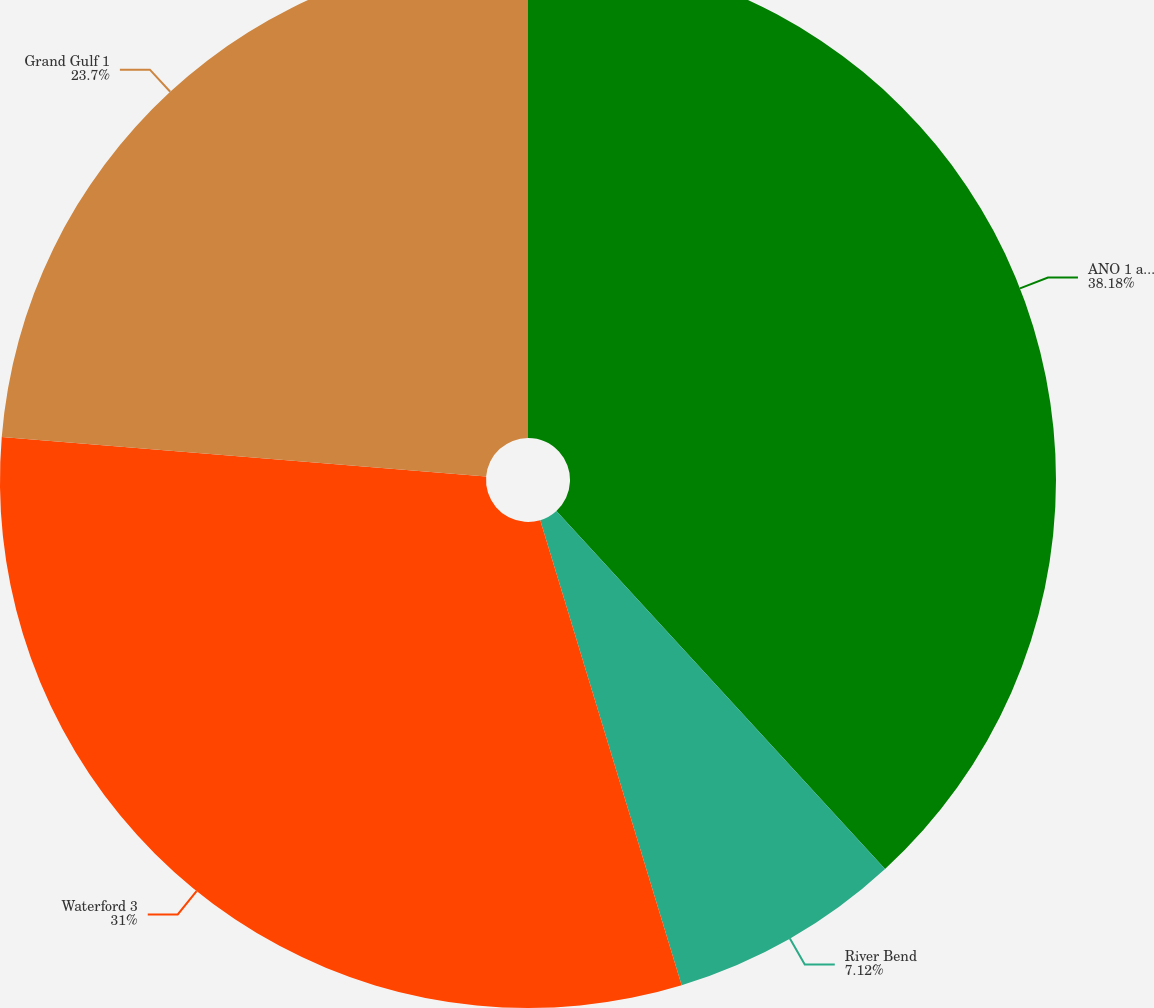<chart> <loc_0><loc_0><loc_500><loc_500><pie_chart><fcel>ANO 1 and ANO 2<fcel>River Bend<fcel>Waterford 3<fcel>Grand Gulf 1<nl><fcel>38.18%<fcel>7.12%<fcel>31.0%<fcel>23.7%<nl></chart> 